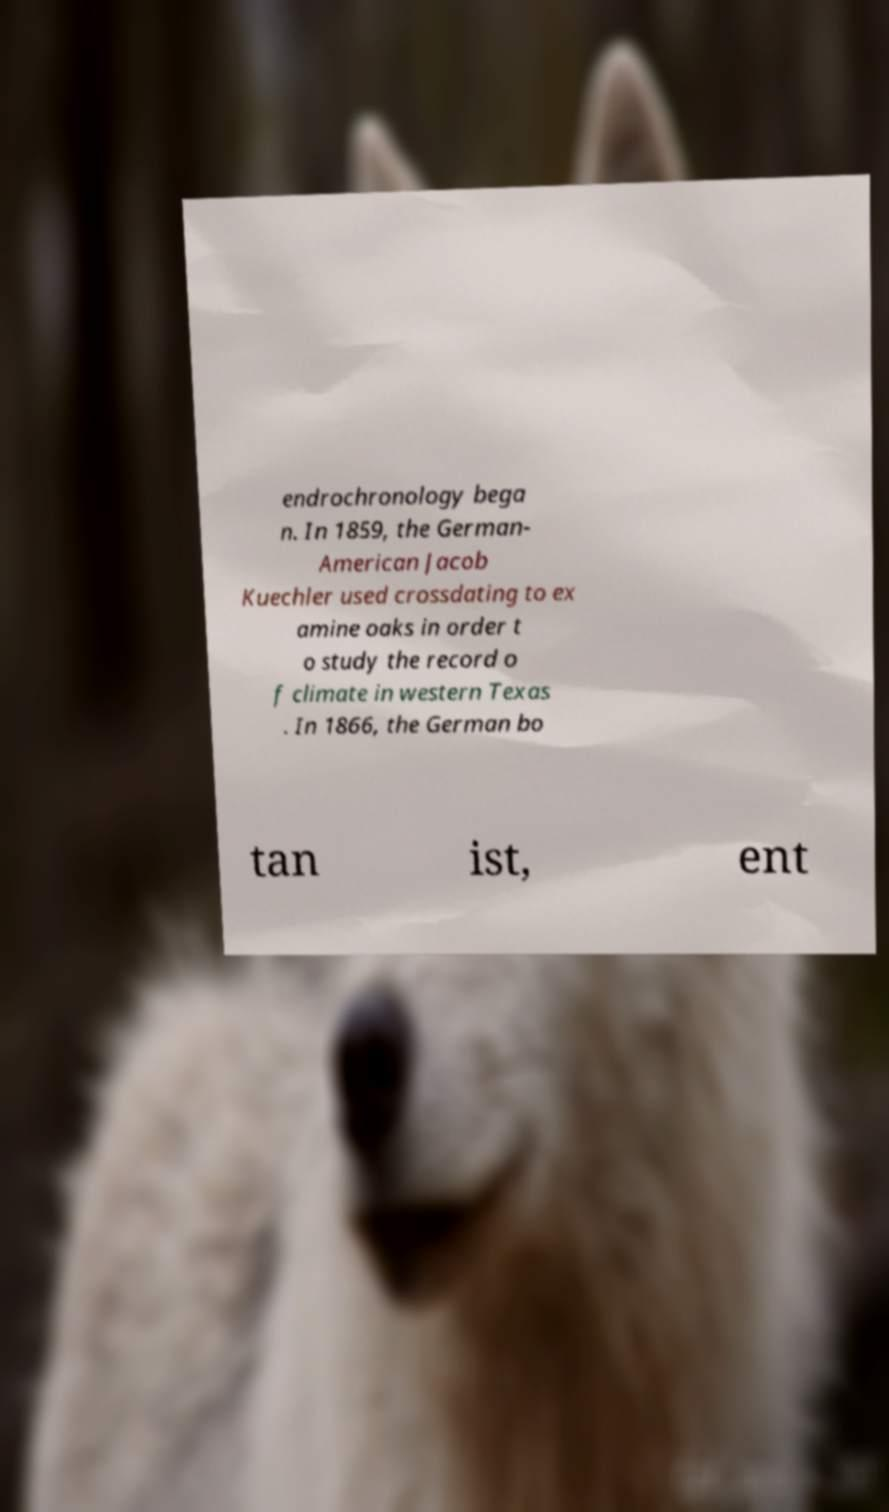There's text embedded in this image that I need extracted. Can you transcribe it verbatim? endrochronology bega n. In 1859, the German- American Jacob Kuechler used crossdating to ex amine oaks in order t o study the record o f climate in western Texas . In 1866, the German bo tan ist, ent 